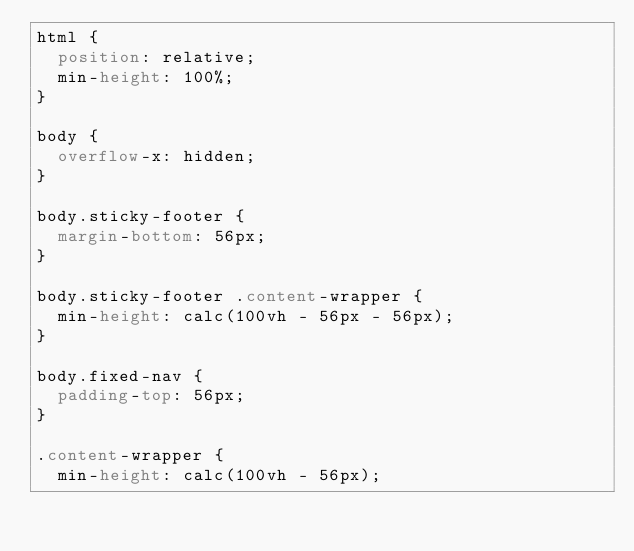<code> <loc_0><loc_0><loc_500><loc_500><_CSS_>html {
  position: relative;
  min-height: 100%;
}

body {
  overflow-x: hidden;
}

body.sticky-footer {
  margin-bottom: 56px;
}

body.sticky-footer .content-wrapper {
  min-height: calc(100vh - 56px - 56px);
}

body.fixed-nav {
  padding-top: 56px;
}

.content-wrapper {
  min-height: calc(100vh - 56px);</code> 